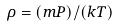Convert formula to latex. <formula><loc_0><loc_0><loc_500><loc_500>\rho = ( m P ) / ( k T )</formula> 